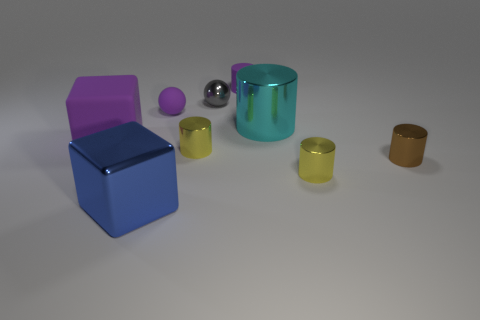How many other objects are the same color as the small matte sphere?
Your answer should be compact. 2. There is a rubber thing that is the same size as the blue cube; what is its shape?
Keep it short and to the point. Cube. There is a yellow cylinder that is behind the brown metal object; how big is it?
Give a very brief answer. Small. There is a tiny cylinder that is behind the purple rubber ball; is its color the same as the rubber thing that is in front of the large cyan metal thing?
Offer a terse response. Yes. What material is the big cyan object left of the small yellow shiny cylinder on the right side of the tiny yellow cylinder behind the small brown thing made of?
Make the answer very short. Metal. Are there any red cubes of the same size as the gray thing?
Your answer should be very brief. No. There is another cube that is the same size as the purple matte cube; what is it made of?
Make the answer very short. Metal. There is a large object on the right side of the tiny purple cylinder; what is its shape?
Offer a very short reply. Cylinder. Is the material of the small yellow cylinder that is on the left side of the cyan cylinder the same as the small yellow cylinder on the right side of the small purple cylinder?
Your response must be concise. Yes. How many purple rubber things are the same shape as the large blue thing?
Your response must be concise. 1. 